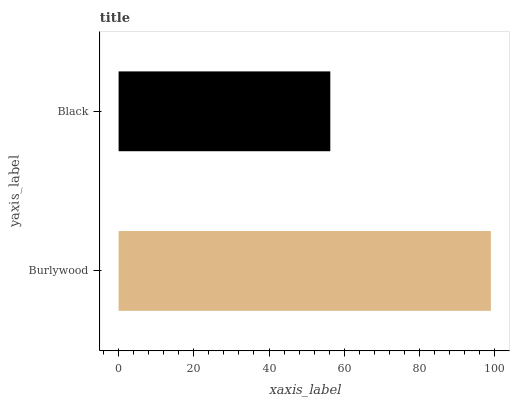Is Black the minimum?
Answer yes or no. Yes. Is Burlywood the maximum?
Answer yes or no. Yes. Is Black the maximum?
Answer yes or no. No. Is Burlywood greater than Black?
Answer yes or no. Yes. Is Black less than Burlywood?
Answer yes or no. Yes. Is Black greater than Burlywood?
Answer yes or no. No. Is Burlywood less than Black?
Answer yes or no. No. Is Burlywood the high median?
Answer yes or no. Yes. Is Black the low median?
Answer yes or no. Yes. Is Black the high median?
Answer yes or no. No. Is Burlywood the low median?
Answer yes or no. No. 